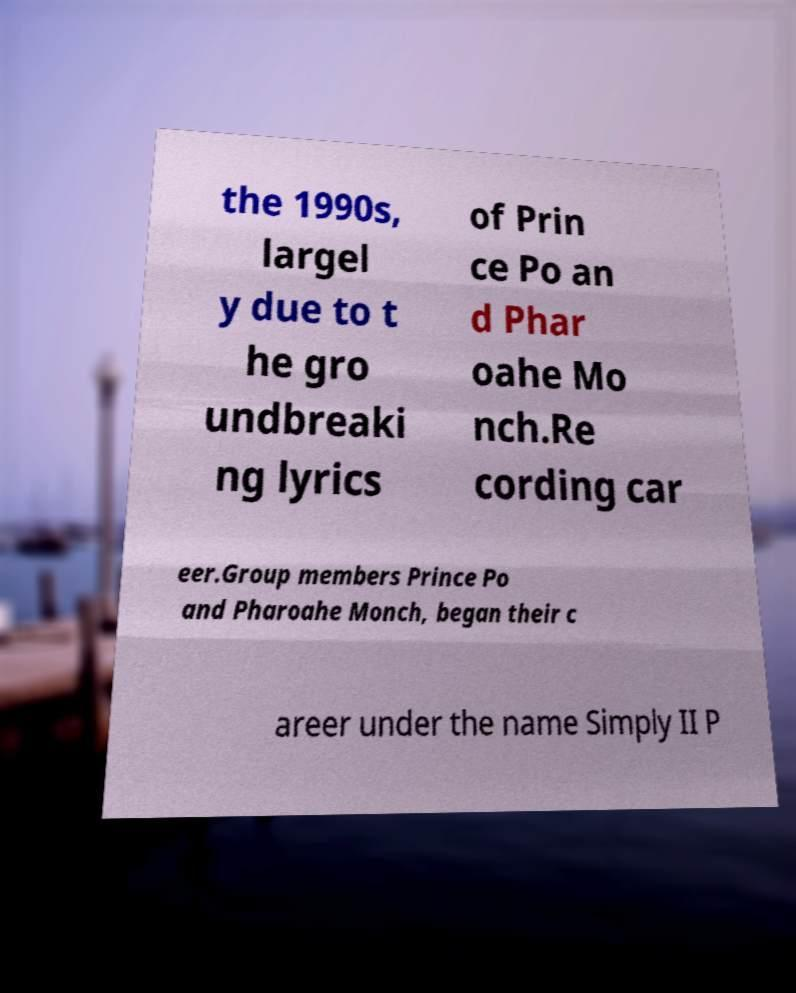For documentation purposes, I need the text within this image transcribed. Could you provide that? the 1990s, largel y due to t he gro undbreaki ng lyrics of Prin ce Po an d Phar oahe Mo nch.Re cording car eer.Group members Prince Po and Pharoahe Monch, began their c areer under the name Simply II P 